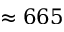Convert formula to latex. <formula><loc_0><loc_0><loc_500><loc_500>\approx 6 6 5</formula> 